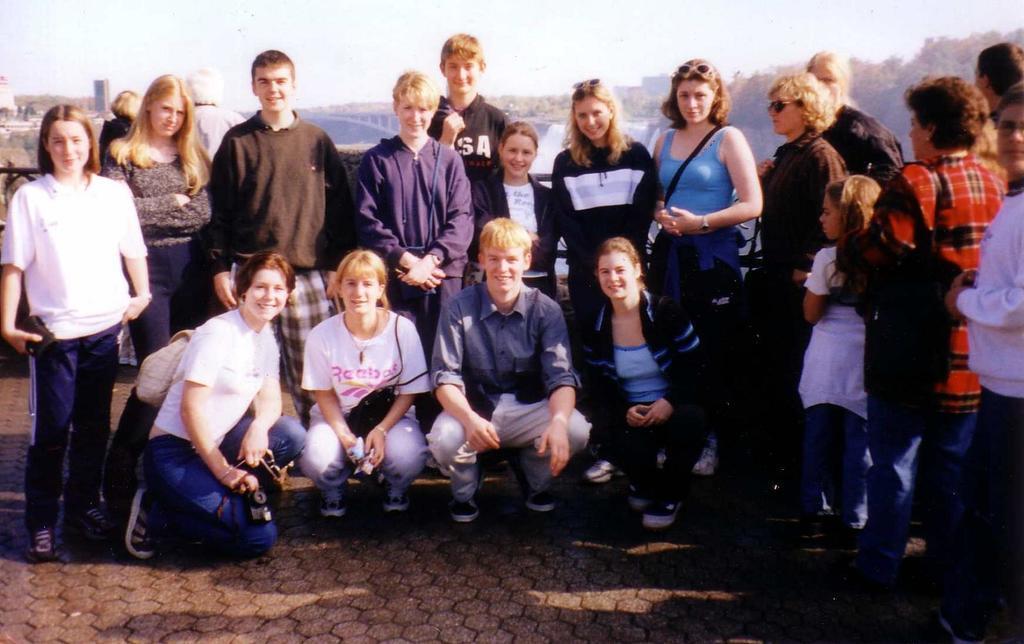Describe this image in one or two sentences. In this image, I can see a group of people standing and four persons in squat position. In the background, I can see buildings, trees, bridge and there is the sky. 